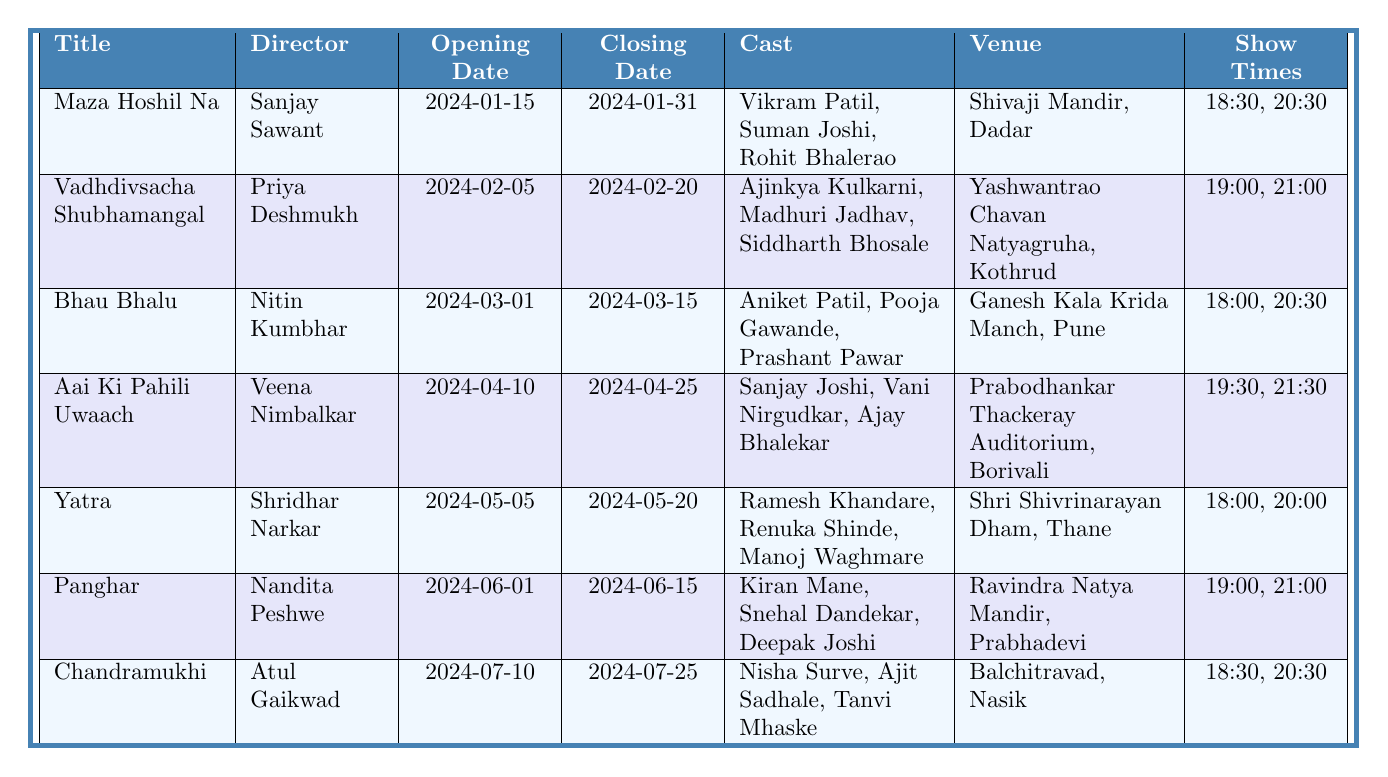What is the title of the production directed by Priya Deshmukh? According to the table, the director's name "Priya Deshmukh" is associated with the production "Vadhdivsacha Shubhamangal".
Answer: Vadhdivsacha Shubhamangal Which production has the earliest opening date? The productions listed have opening dates of "2024-01-15" for "Maza Hoshil Na", "2024-02-05" for "Vadhdivsacha Shubhamangal", and so on. The earliest date among them is "2024-01-15".
Answer: Maza Hoshil Na How many members are in the cast of "Bhau Bhalu"? The cast of "Bhau Bhalu" includes "Aniket Patil", "Pooja Gawande", and "Prashant Pawar", which totals to three members.
Answer: 3 Which venue hosts the production "Chandramukhi"? The table specifies that "Chandramukhi" is hosted at "Balchitravad, Nasik".
Answer: Balchitravad, Nasik What is the last day of the production "Panghar"? Looking at the table, "Panghar" has a closing date of "2024-06-15".
Answer: 2024-06-15 Which production features the show times "19:00" and "21:00"? By reviewing the show times in the table, "Vadhdivsacha Shubhamangal" and "Panghar" both have these times listed, confirming that two productions feature those times.
Answer: Vadhdivsacha Shubhamangal, Panghar Are there any productions scheduled in the month of May 2024? The table indicates that there is indeed a production titled "Yatra" that is scheduled from "2024-05-05" to "2024-05-20", confirming productions in May.
Answer: Yes What is the average opening time for the shows of the production "Aai Ki Pahili Uwaach"? The opening times for "Aai Ki Pahili Uwaach" are "19:30" and "21:30". To find the average: convert times to 24-hour format (19:30 = 19.5, 21:30 = 21.5). Their total is 41, divided by 2 gives 20.5 or 20:30 as the average.
Answer: 20:30 Which production has the maximum show time slots? The productions listed have two show times each. Therefore, since all production have two show times, none has a greater number of slots than another.
Answer: All have the same number Which production has the longest duration between opening and closing dates? By calculating the differences between the opening and closing dates we find "Maza Hoshil Na" (16 days), "Vadhdivsacha Shubhamangal" (15 days), and so on. The longest is "Aai Ki Pahili Uwaach" with 15 days, while "Maza Hoshil Na" and "Yatra" have a longer duration, both having 15 days.
Answer: Aai Ki Pahili Uwaach 